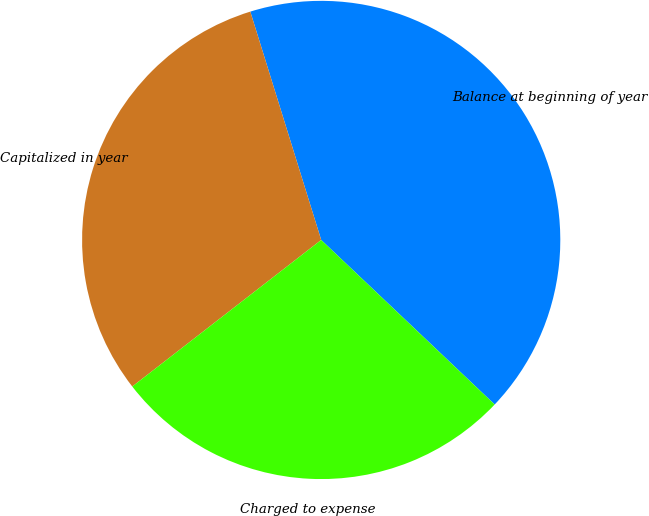Convert chart. <chart><loc_0><loc_0><loc_500><loc_500><pie_chart><fcel>Balance at beginning of year<fcel>Capitalized in year<fcel>Charged to expense<nl><fcel>41.87%<fcel>30.71%<fcel>27.42%<nl></chart> 